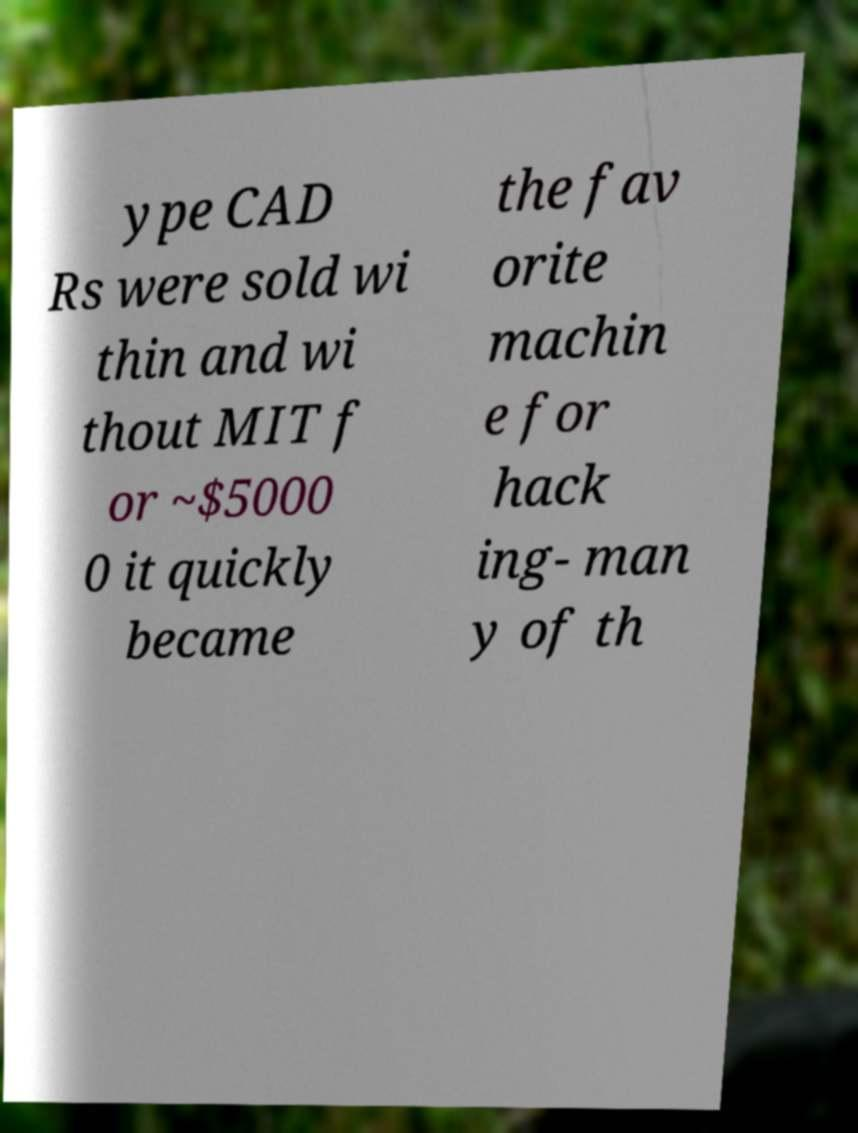Could you extract and type out the text from this image? ype CAD Rs were sold wi thin and wi thout MIT f or ~$5000 0 it quickly became the fav orite machin e for hack ing- man y of th 